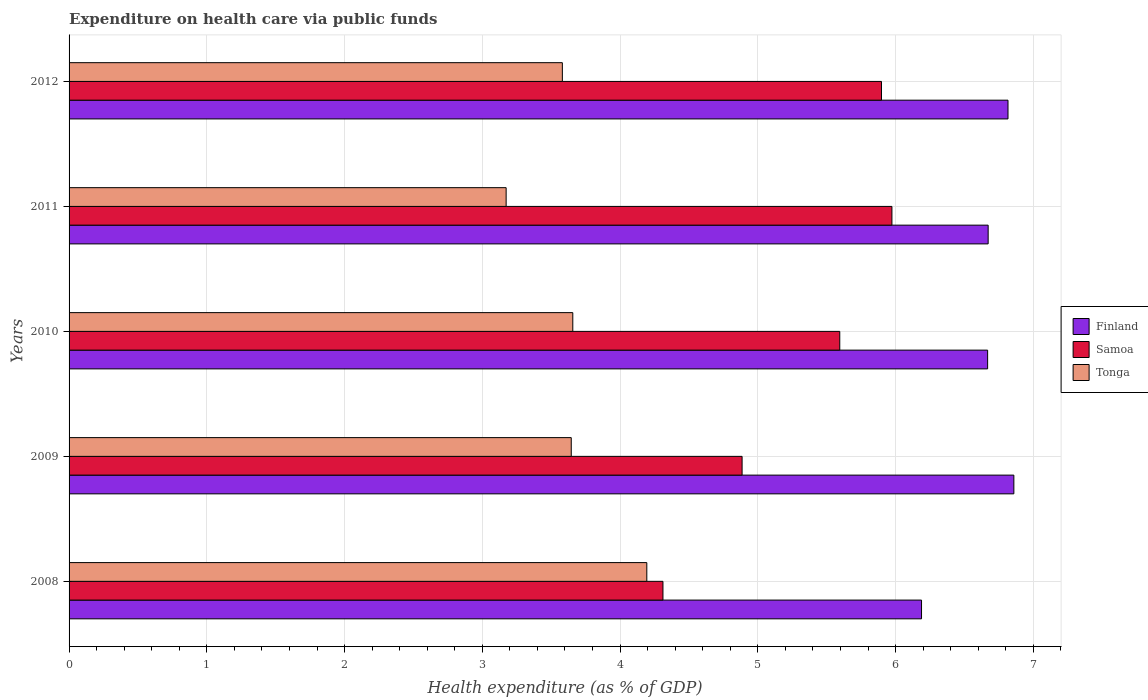Are the number of bars per tick equal to the number of legend labels?
Offer a terse response. Yes. How many bars are there on the 4th tick from the top?
Ensure brevity in your answer.  3. How many bars are there on the 1st tick from the bottom?
Keep it short and to the point. 3. What is the label of the 2nd group of bars from the top?
Your answer should be very brief. 2011. In how many cases, is the number of bars for a given year not equal to the number of legend labels?
Your answer should be very brief. 0. What is the expenditure made on health care in Finland in 2009?
Your response must be concise. 6.86. Across all years, what is the maximum expenditure made on health care in Finland?
Provide a short and direct response. 6.86. Across all years, what is the minimum expenditure made on health care in Finland?
Ensure brevity in your answer.  6.19. In which year was the expenditure made on health care in Samoa minimum?
Your answer should be compact. 2008. What is the total expenditure made on health care in Samoa in the graph?
Offer a terse response. 26.66. What is the difference between the expenditure made on health care in Tonga in 2009 and that in 2012?
Provide a succinct answer. 0.06. What is the difference between the expenditure made on health care in Finland in 2009 and the expenditure made on health care in Samoa in 2011?
Your response must be concise. 0.89. What is the average expenditure made on health care in Samoa per year?
Ensure brevity in your answer.  5.33. In the year 2010, what is the difference between the expenditure made on health care in Tonga and expenditure made on health care in Finland?
Keep it short and to the point. -3.01. In how many years, is the expenditure made on health care in Tonga greater than 2.8 %?
Make the answer very short. 5. What is the ratio of the expenditure made on health care in Samoa in 2008 to that in 2012?
Provide a short and direct response. 0.73. Is the expenditure made on health care in Finland in 2010 less than that in 2011?
Make the answer very short. Yes. Is the difference between the expenditure made on health care in Tonga in 2010 and 2011 greater than the difference between the expenditure made on health care in Finland in 2010 and 2011?
Ensure brevity in your answer.  Yes. What is the difference between the highest and the second highest expenditure made on health care in Finland?
Keep it short and to the point. 0.04. What is the difference between the highest and the lowest expenditure made on health care in Samoa?
Ensure brevity in your answer.  1.66. In how many years, is the expenditure made on health care in Samoa greater than the average expenditure made on health care in Samoa taken over all years?
Provide a short and direct response. 3. Is the sum of the expenditure made on health care in Finland in 2008 and 2011 greater than the maximum expenditure made on health care in Tonga across all years?
Your answer should be very brief. Yes. What does the 1st bar from the top in 2008 represents?
Give a very brief answer. Tonga. What does the 3rd bar from the bottom in 2011 represents?
Provide a succinct answer. Tonga. Is it the case that in every year, the sum of the expenditure made on health care in Finland and expenditure made on health care in Tonga is greater than the expenditure made on health care in Samoa?
Your response must be concise. Yes. How many bars are there?
Your answer should be very brief. 15. How many years are there in the graph?
Offer a terse response. 5. Are the values on the major ticks of X-axis written in scientific E-notation?
Your answer should be very brief. No. Does the graph contain any zero values?
Your response must be concise. No. Does the graph contain grids?
Provide a succinct answer. Yes. What is the title of the graph?
Make the answer very short. Expenditure on health care via public funds. What is the label or title of the X-axis?
Your answer should be very brief. Health expenditure (as % of GDP). What is the Health expenditure (as % of GDP) in Finland in 2008?
Provide a short and direct response. 6.19. What is the Health expenditure (as % of GDP) of Samoa in 2008?
Offer a terse response. 4.31. What is the Health expenditure (as % of GDP) of Tonga in 2008?
Offer a very short reply. 4.19. What is the Health expenditure (as % of GDP) of Finland in 2009?
Offer a very short reply. 6.86. What is the Health expenditure (as % of GDP) of Samoa in 2009?
Make the answer very short. 4.89. What is the Health expenditure (as % of GDP) in Tonga in 2009?
Keep it short and to the point. 3.65. What is the Health expenditure (as % of GDP) in Finland in 2010?
Keep it short and to the point. 6.67. What is the Health expenditure (as % of GDP) in Samoa in 2010?
Your response must be concise. 5.6. What is the Health expenditure (as % of GDP) in Tonga in 2010?
Ensure brevity in your answer.  3.66. What is the Health expenditure (as % of GDP) in Finland in 2011?
Ensure brevity in your answer.  6.67. What is the Health expenditure (as % of GDP) of Samoa in 2011?
Make the answer very short. 5.97. What is the Health expenditure (as % of GDP) in Tonga in 2011?
Keep it short and to the point. 3.17. What is the Health expenditure (as % of GDP) of Finland in 2012?
Keep it short and to the point. 6.82. What is the Health expenditure (as % of GDP) of Samoa in 2012?
Keep it short and to the point. 5.9. What is the Health expenditure (as % of GDP) in Tonga in 2012?
Your answer should be very brief. 3.58. Across all years, what is the maximum Health expenditure (as % of GDP) of Finland?
Your response must be concise. 6.86. Across all years, what is the maximum Health expenditure (as % of GDP) in Samoa?
Give a very brief answer. 5.97. Across all years, what is the maximum Health expenditure (as % of GDP) of Tonga?
Your response must be concise. 4.19. Across all years, what is the minimum Health expenditure (as % of GDP) of Finland?
Keep it short and to the point. 6.19. Across all years, what is the minimum Health expenditure (as % of GDP) of Samoa?
Offer a very short reply. 4.31. Across all years, what is the minimum Health expenditure (as % of GDP) of Tonga?
Offer a terse response. 3.17. What is the total Health expenditure (as % of GDP) of Finland in the graph?
Give a very brief answer. 33.2. What is the total Health expenditure (as % of GDP) of Samoa in the graph?
Provide a short and direct response. 26.66. What is the total Health expenditure (as % of GDP) of Tonga in the graph?
Provide a short and direct response. 18.25. What is the difference between the Health expenditure (as % of GDP) of Finland in 2008 and that in 2009?
Provide a succinct answer. -0.67. What is the difference between the Health expenditure (as % of GDP) of Samoa in 2008 and that in 2009?
Keep it short and to the point. -0.57. What is the difference between the Health expenditure (as % of GDP) of Tonga in 2008 and that in 2009?
Your response must be concise. 0.55. What is the difference between the Health expenditure (as % of GDP) of Finland in 2008 and that in 2010?
Give a very brief answer. -0.48. What is the difference between the Health expenditure (as % of GDP) in Samoa in 2008 and that in 2010?
Offer a terse response. -1.28. What is the difference between the Health expenditure (as % of GDP) of Tonga in 2008 and that in 2010?
Offer a very short reply. 0.54. What is the difference between the Health expenditure (as % of GDP) in Finland in 2008 and that in 2011?
Give a very brief answer. -0.48. What is the difference between the Health expenditure (as % of GDP) of Samoa in 2008 and that in 2011?
Your answer should be very brief. -1.66. What is the difference between the Health expenditure (as % of GDP) in Tonga in 2008 and that in 2011?
Offer a very short reply. 1.02. What is the difference between the Health expenditure (as % of GDP) of Finland in 2008 and that in 2012?
Your response must be concise. -0.63. What is the difference between the Health expenditure (as % of GDP) of Samoa in 2008 and that in 2012?
Keep it short and to the point. -1.59. What is the difference between the Health expenditure (as % of GDP) in Tonga in 2008 and that in 2012?
Provide a short and direct response. 0.61. What is the difference between the Health expenditure (as % of GDP) of Finland in 2009 and that in 2010?
Your response must be concise. 0.19. What is the difference between the Health expenditure (as % of GDP) in Samoa in 2009 and that in 2010?
Your response must be concise. -0.71. What is the difference between the Health expenditure (as % of GDP) of Tonga in 2009 and that in 2010?
Provide a short and direct response. -0.01. What is the difference between the Health expenditure (as % of GDP) of Finland in 2009 and that in 2011?
Make the answer very short. 0.19. What is the difference between the Health expenditure (as % of GDP) of Samoa in 2009 and that in 2011?
Make the answer very short. -1.09. What is the difference between the Health expenditure (as % of GDP) of Tonga in 2009 and that in 2011?
Offer a very short reply. 0.47. What is the difference between the Health expenditure (as % of GDP) in Finland in 2009 and that in 2012?
Offer a terse response. 0.04. What is the difference between the Health expenditure (as % of GDP) in Samoa in 2009 and that in 2012?
Give a very brief answer. -1.01. What is the difference between the Health expenditure (as % of GDP) in Tonga in 2009 and that in 2012?
Ensure brevity in your answer.  0.06. What is the difference between the Health expenditure (as % of GDP) of Finland in 2010 and that in 2011?
Your answer should be very brief. -0. What is the difference between the Health expenditure (as % of GDP) of Samoa in 2010 and that in 2011?
Your answer should be compact. -0.38. What is the difference between the Health expenditure (as % of GDP) in Tonga in 2010 and that in 2011?
Your answer should be very brief. 0.48. What is the difference between the Health expenditure (as % of GDP) of Finland in 2010 and that in 2012?
Your answer should be very brief. -0.15. What is the difference between the Health expenditure (as % of GDP) of Samoa in 2010 and that in 2012?
Provide a short and direct response. -0.3. What is the difference between the Health expenditure (as % of GDP) of Tonga in 2010 and that in 2012?
Provide a short and direct response. 0.08. What is the difference between the Health expenditure (as % of GDP) of Finland in 2011 and that in 2012?
Offer a terse response. -0.14. What is the difference between the Health expenditure (as % of GDP) in Samoa in 2011 and that in 2012?
Provide a succinct answer. 0.08. What is the difference between the Health expenditure (as % of GDP) of Tonga in 2011 and that in 2012?
Your answer should be very brief. -0.41. What is the difference between the Health expenditure (as % of GDP) in Finland in 2008 and the Health expenditure (as % of GDP) in Samoa in 2009?
Give a very brief answer. 1.3. What is the difference between the Health expenditure (as % of GDP) of Finland in 2008 and the Health expenditure (as % of GDP) of Tonga in 2009?
Your answer should be very brief. 2.54. What is the difference between the Health expenditure (as % of GDP) of Samoa in 2008 and the Health expenditure (as % of GDP) of Tonga in 2009?
Provide a succinct answer. 0.67. What is the difference between the Health expenditure (as % of GDP) in Finland in 2008 and the Health expenditure (as % of GDP) in Samoa in 2010?
Your response must be concise. 0.59. What is the difference between the Health expenditure (as % of GDP) of Finland in 2008 and the Health expenditure (as % of GDP) of Tonga in 2010?
Offer a very short reply. 2.53. What is the difference between the Health expenditure (as % of GDP) in Samoa in 2008 and the Health expenditure (as % of GDP) in Tonga in 2010?
Make the answer very short. 0.65. What is the difference between the Health expenditure (as % of GDP) of Finland in 2008 and the Health expenditure (as % of GDP) of Samoa in 2011?
Offer a very short reply. 0.21. What is the difference between the Health expenditure (as % of GDP) in Finland in 2008 and the Health expenditure (as % of GDP) in Tonga in 2011?
Keep it short and to the point. 3.02. What is the difference between the Health expenditure (as % of GDP) of Samoa in 2008 and the Health expenditure (as % of GDP) of Tonga in 2011?
Offer a very short reply. 1.14. What is the difference between the Health expenditure (as % of GDP) in Finland in 2008 and the Health expenditure (as % of GDP) in Samoa in 2012?
Make the answer very short. 0.29. What is the difference between the Health expenditure (as % of GDP) of Finland in 2008 and the Health expenditure (as % of GDP) of Tonga in 2012?
Your answer should be very brief. 2.61. What is the difference between the Health expenditure (as % of GDP) in Samoa in 2008 and the Health expenditure (as % of GDP) in Tonga in 2012?
Ensure brevity in your answer.  0.73. What is the difference between the Health expenditure (as % of GDP) in Finland in 2009 and the Health expenditure (as % of GDP) in Samoa in 2010?
Offer a terse response. 1.26. What is the difference between the Health expenditure (as % of GDP) of Finland in 2009 and the Health expenditure (as % of GDP) of Tonga in 2010?
Provide a short and direct response. 3.2. What is the difference between the Health expenditure (as % of GDP) in Samoa in 2009 and the Health expenditure (as % of GDP) in Tonga in 2010?
Offer a very short reply. 1.23. What is the difference between the Health expenditure (as % of GDP) in Finland in 2009 and the Health expenditure (as % of GDP) in Samoa in 2011?
Ensure brevity in your answer.  0.89. What is the difference between the Health expenditure (as % of GDP) of Finland in 2009 and the Health expenditure (as % of GDP) of Tonga in 2011?
Provide a short and direct response. 3.69. What is the difference between the Health expenditure (as % of GDP) of Samoa in 2009 and the Health expenditure (as % of GDP) of Tonga in 2011?
Your response must be concise. 1.71. What is the difference between the Health expenditure (as % of GDP) of Finland in 2009 and the Health expenditure (as % of GDP) of Samoa in 2012?
Provide a short and direct response. 0.96. What is the difference between the Health expenditure (as % of GDP) in Finland in 2009 and the Health expenditure (as % of GDP) in Tonga in 2012?
Ensure brevity in your answer.  3.28. What is the difference between the Health expenditure (as % of GDP) in Samoa in 2009 and the Health expenditure (as % of GDP) in Tonga in 2012?
Give a very brief answer. 1.3. What is the difference between the Health expenditure (as % of GDP) in Finland in 2010 and the Health expenditure (as % of GDP) in Samoa in 2011?
Your response must be concise. 0.69. What is the difference between the Health expenditure (as % of GDP) of Finland in 2010 and the Health expenditure (as % of GDP) of Tonga in 2011?
Give a very brief answer. 3.5. What is the difference between the Health expenditure (as % of GDP) of Samoa in 2010 and the Health expenditure (as % of GDP) of Tonga in 2011?
Make the answer very short. 2.42. What is the difference between the Health expenditure (as % of GDP) in Finland in 2010 and the Health expenditure (as % of GDP) in Samoa in 2012?
Give a very brief answer. 0.77. What is the difference between the Health expenditure (as % of GDP) in Finland in 2010 and the Health expenditure (as % of GDP) in Tonga in 2012?
Make the answer very short. 3.09. What is the difference between the Health expenditure (as % of GDP) of Samoa in 2010 and the Health expenditure (as % of GDP) of Tonga in 2012?
Give a very brief answer. 2.01. What is the difference between the Health expenditure (as % of GDP) in Finland in 2011 and the Health expenditure (as % of GDP) in Samoa in 2012?
Your answer should be very brief. 0.77. What is the difference between the Health expenditure (as % of GDP) of Finland in 2011 and the Health expenditure (as % of GDP) of Tonga in 2012?
Offer a very short reply. 3.09. What is the difference between the Health expenditure (as % of GDP) of Samoa in 2011 and the Health expenditure (as % of GDP) of Tonga in 2012?
Offer a terse response. 2.39. What is the average Health expenditure (as % of GDP) of Finland per year?
Your answer should be very brief. 6.64. What is the average Health expenditure (as % of GDP) of Samoa per year?
Give a very brief answer. 5.33. What is the average Health expenditure (as % of GDP) of Tonga per year?
Provide a short and direct response. 3.65. In the year 2008, what is the difference between the Health expenditure (as % of GDP) of Finland and Health expenditure (as % of GDP) of Samoa?
Ensure brevity in your answer.  1.88. In the year 2008, what is the difference between the Health expenditure (as % of GDP) of Finland and Health expenditure (as % of GDP) of Tonga?
Ensure brevity in your answer.  1.99. In the year 2008, what is the difference between the Health expenditure (as % of GDP) in Samoa and Health expenditure (as % of GDP) in Tonga?
Make the answer very short. 0.12. In the year 2009, what is the difference between the Health expenditure (as % of GDP) in Finland and Health expenditure (as % of GDP) in Samoa?
Your answer should be very brief. 1.97. In the year 2009, what is the difference between the Health expenditure (as % of GDP) of Finland and Health expenditure (as % of GDP) of Tonga?
Provide a succinct answer. 3.21. In the year 2009, what is the difference between the Health expenditure (as % of GDP) of Samoa and Health expenditure (as % of GDP) of Tonga?
Make the answer very short. 1.24. In the year 2010, what is the difference between the Health expenditure (as % of GDP) in Finland and Health expenditure (as % of GDP) in Samoa?
Keep it short and to the point. 1.07. In the year 2010, what is the difference between the Health expenditure (as % of GDP) in Finland and Health expenditure (as % of GDP) in Tonga?
Keep it short and to the point. 3.01. In the year 2010, what is the difference between the Health expenditure (as % of GDP) of Samoa and Health expenditure (as % of GDP) of Tonga?
Your answer should be very brief. 1.94. In the year 2011, what is the difference between the Health expenditure (as % of GDP) in Finland and Health expenditure (as % of GDP) in Samoa?
Your response must be concise. 0.7. In the year 2011, what is the difference between the Health expenditure (as % of GDP) of Finland and Health expenditure (as % of GDP) of Tonga?
Give a very brief answer. 3.5. In the year 2011, what is the difference between the Health expenditure (as % of GDP) of Samoa and Health expenditure (as % of GDP) of Tonga?
Give a very brief answer. 2.8. In the year 2012, what is the difference between the Health expenditure (as % of GDP) of Finland and Health expenditure (as % of GDP) of Samoa?
Offer a very short reply. 0.92. In the year 2012, what is the difference between the Health expenditure (as % of GDP) in Finland and Health expenditure (as % of GDP) in Tonga?
Offer a terse response. 3.24. In the year 2012, what is the difference between the Health expenditure (as % of GDP) of Samoa and Health expenditure (as % of GDP) of Tonga?
Your response must be concise. 2.32. What is the ratio of the Health expenditure (as % of GDP) of Finland in 2008 to that in 2009?
Provide a short and direct response. 0.9. What is the ratio of the Health expenditure (as % of GDP) of Samoa in 2008 to that in 2009?
Your response must be concise. 0.88. What is the ratio of the Health expenditure (as % of GDP) of Tonga in 2008 to that in 2009?
Your answer should be very brief. 1.15. What is the ratio of the Health expenditure (as % of GDP) of Finland in 2008 to that in 2010?
Offer a terse response. 0.93. What is the ratio of the Health expenditure (as % of GDP) of Samoa in 2008 to that in 2010?
Give a very brief answer. 0.77. What is the ratio of the Health expenditure (as % of GDP) of Tonga in 2008 to that in 2010?
Make the answer very short. 1.15. What is the ratio of the Health expenditure (as % of GDP) of Finland in 2008 to that in 2011?
Your response must be concise. 0.93. What is the ratio of the Health expenditure (as % of GDP) of Samoa in 2008 to that in 2011?
Your response must be concise. 0.72. What is the ratio of the Health expenditure (as % of GDP) in Tonga in 2008 to that in 2011?
Your answer should be very brief. 1.32. What is the ratio of the Health expenditure (as % of GDP) in Finland in 2008 to that in 2012?
Provide a short and direct response. 0.91. What is the ratio of the Health expenditure (as % of GDP) in Samoa in 2008 to that in 2012?
Offer a terse response. 0.73. What is the ratio of the Health expenditure (as % of GDP) of Tonga in 2008 to that in 2012?
Your answer should be compact. 1.17. What is the ratio of the Health expenditure (as % of GDP) in Finland in 2009 to that in 2010?
Make the answer very short. 1.03. What is the ratio of the Health expenditure (as % of GDP) in Samoa in 2009 to that in 2010?
Offer a terse response. 0.87. What is the ratio of the Health expenditure (as % of GDP) in Tonga in 2009 to that in 2010?
Keep it short and to the point. 1. What is the ratio of the Health expenditure (as % of GDP) of Finland in 2009 to that in 2011?
Ensure brevity in your answer.  1.03. What is the ratio of the Health expenditure (as % of GDP) of Samoa in 2009 to that in 2011?
Ensure brevity in your answer.  0.82. What is the ratio of the Health expenditure (as % of GDP) of Tonga in 2009 to that in 2011?
Your answer should be compact. 1.15. What is the ratio of the Health expenditure (as % of GDP) of Finland in 2009 to that in 2012?
Your answer should be compact. 1.01. What is the ratio of the Health expenditure (as % of GDP) in Samoa in 2009 to that in 2012?
Provide a succinct answer. 0.83. What is the ratio of the Health expenditure (as % of GDP) of Samoa in 2010 to that in 2011?
Your response must be concise. 0.94. What is the ratio of the Health expenditure (as % of GDP) of Tonga in 2010 to that in 2011?
Offer a terse response. 1.15. What is the ratio of the Health expenditure (as % of GDP) of Finland in 2010 to that in 2012?
Ensure brevity in your answer.  0.98. What is the ratio of the Health expenditure (as % of GDP) of Samoa in 2010 to that in 2012?
Your answer should be very brief. 0.95. What is the ratio of the Health expenditure (as % of GDP) of Tonga in 2010 to that in 2012?
Make the answer very short. 1.02. What is the ratio of the Health expenditure (as % of GDP) in Finland in 2011 to that in 2012?
Offer a terse response. 0.98. What is the ratio of the Health expenditure (as % of GDP) in Samoa in 2011 to that in 2012?
Ensure brevity in your answer.  1.01. What is the ratio of the Health expenditure (as % of GDP) in Tonga in 2011 to that in 2012?
Ensure brevity in your answer.  0.89. What is the difference between the highest and the second highest Health expenditure (as % of GDP) of Finland?
Your response must be concise. 0.04. What is the difference between the highest and the second highest Health expenditure (as % of GDP) in Samoa?
Make the answer very short. 0.08. What is the difference between the highest and the second highest Health expenditure (as % of GDP) in Tonga?
Provide a succinct answer. 0.54. What is the difference between the highest and the lowest Health expenditure (as % of GDP) in Finland?
Your answer should be very brief. 0.67. What is the difference between the highest and the lowest Health expenditure (as % of GDP) in Samoa?
Offer a terse response. 1.66. What is the difference between the highest and the lowest Health expenditure (as % of GDP) of Tonga?
Make the answer very short. 1.02. 